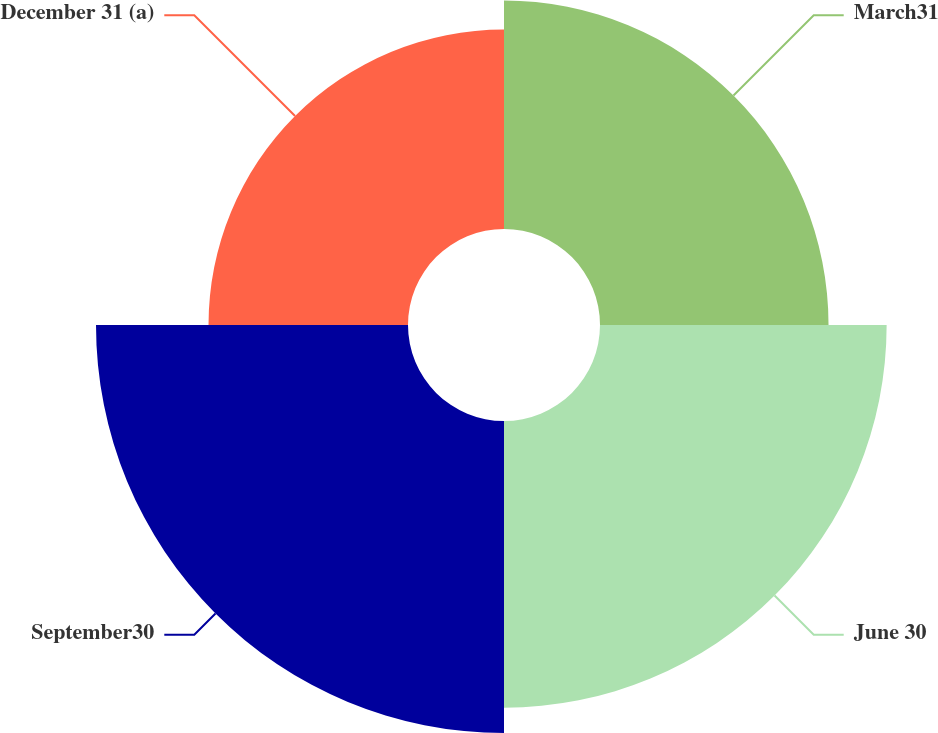Convert chart. <chart><loc_0><loc_0><loc_500><loc_500><pie_chart><fcel>March31<fcel>June 30<fcel>September30<fcel>December 31 (a)<nl><fcel>22.26%<fcel>27.92%<fcel>30.39%<fcel>19.43%<nl></chart> 